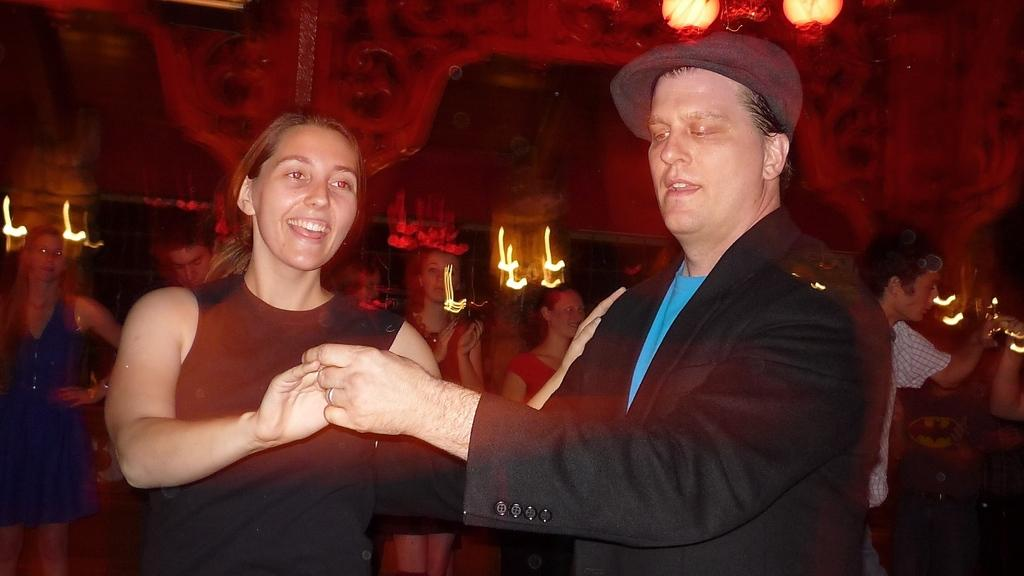How many people are present in the image? There are two people, a man and a woman, present in the image. What are the man and woman doing in the image? The man and woman are standing. Can you describe the background of the image? There are people visible in the background of the image. What type of reaction can be seen from the fireman in the image? There is no fireman present in the image, so it is not possible to determine any reactions from a fireman. 